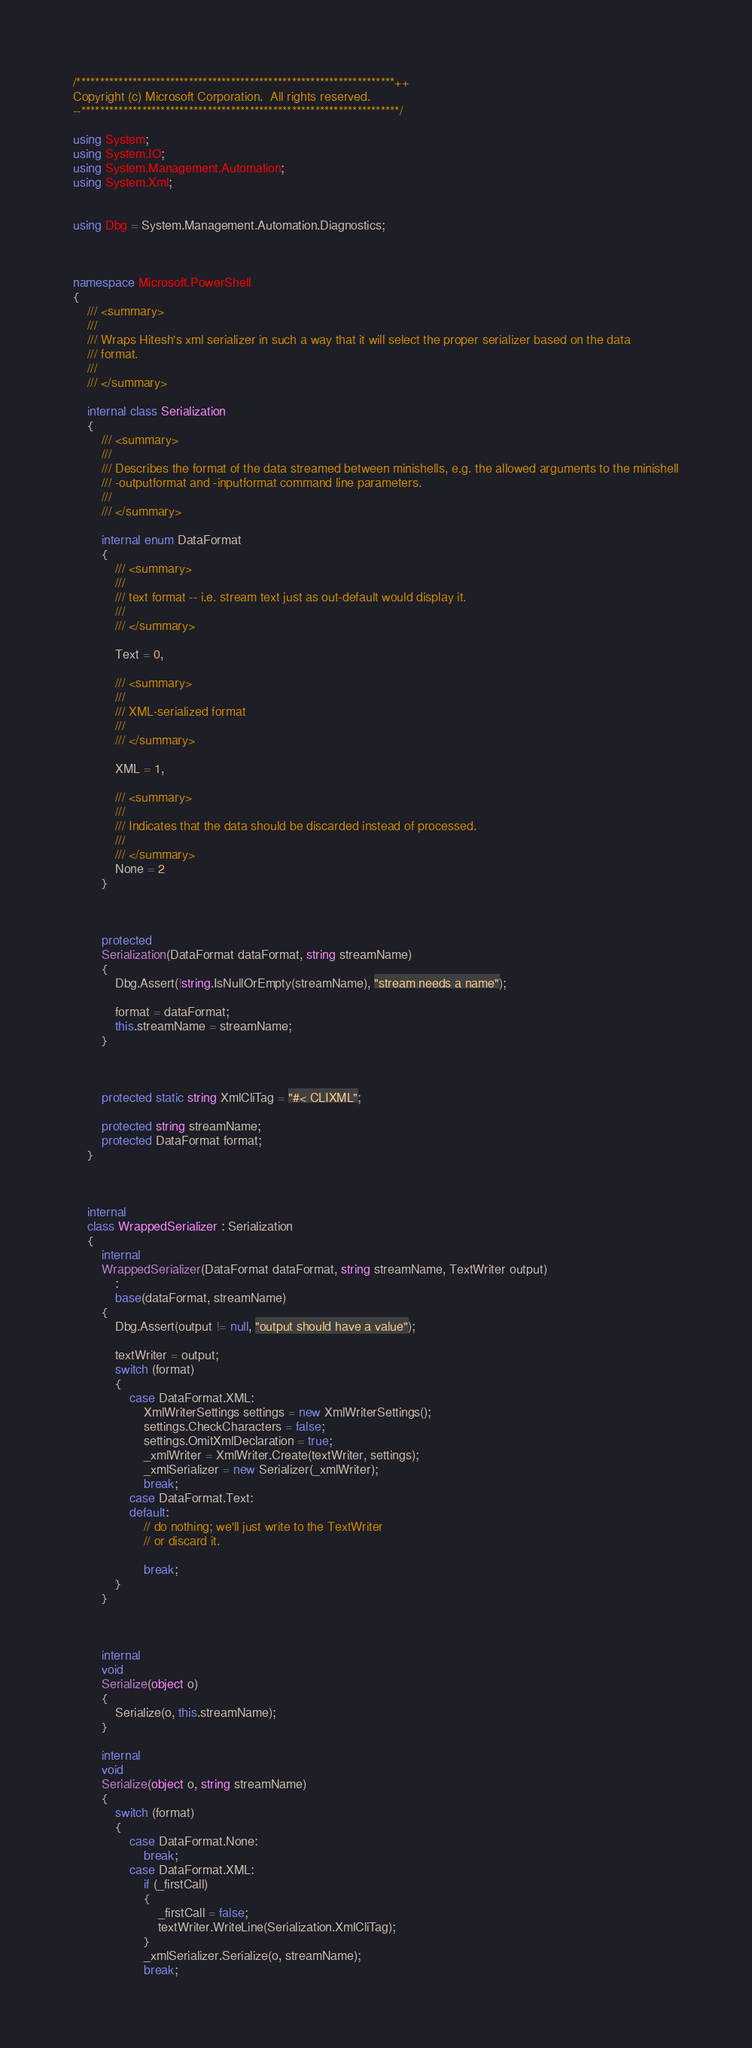<code> <loc_0><loc_0><loc_500><loc_500><_C#_>/********************************************************************++
Copyright (c) Microsoft Corporation.  All rights reserved.
--********************************************************************/

using System;
using System.IO;
using System.Management.Automation;
using System.Xml;


using Dbg = System.Management.Automation.Diagnostics;



namespace Microsoft.PowerShell
{
    /// <summary>
    ///
    /// Wraps Hitesh's xml serializer in such a way that it will select the proper serializer based on the data
    /// format.
    ///
    /// </summary>

    internal class Serialization
    {
        /// <summary>
        ///
        /// Describes the format of the data streamed between minishells, e.g. the allowed arguments to the minishell
        /// -outputformat and -inputformat command line parameters.
        ///
        /// </summary>

        internal enum DataFormat
        {
            /// <summary>
            ///
            /// text format -- i.e. stream text just as out-default would display it.
            ///
            /// </summary>

            Text = 0,

            /// <summary>
            ///
            /// XML-serialized format
            ///
            /// </summary>

            XML = 1,

            /// <summary>
            ///
            /// Indicates that the data should be discarded instead of processed.
            ///
            /// </summary>
            None = 2
        }



        protected
        Serialization(DataFormat dataFormat, string streamName)
        {
            Dbg.Assert(!string.IsNullOrEmpty(streamName), "stream needs a name");

            format = dataFormat;
            this.streamName = streamName;
        }



        protected static string XmlCliTag = "#< CLIXML";

        protected string streamName;
        protected DataFormat format;
    }



    internal
    class WrappedSerializer : Serialization
    {
        internal
        WrappedSerializer(DataFormat dataFormat, string streamName, TextWriter output)
            :
            base(dataFormat, streamName)
        {
            Dbg.Assert(output != null, "output should have a value");

            textWriter = output;
            switch (format)
            {
                case DataFormat.XML:
                    XmlWriterSettings settings = new XmlWriterSettings();
                    settings.CheckCharacters = false;
                    settings.OmitXmlDeclaration = true;
                    _xmlWriter = XmlWriter.Create(textWriter, settings);
                    _xmlSerializer = new Serializer(_xmlWriter);
                    break;
                case DataFormat.Text:
                default:
                    // do nothing; we'll just write to the TextWriter
                    // or discard it.

                    break;
            }
        }



        internal
        void
        Serialize(object o)
        {
            Serialize(o, this.streamName);
        }

        internal
        void
        Serialize(object o, string streamName)
        {
            switch (format)
            {
                case DataFormat.None:
                    break;
                case DataFormat.XML:
                    if (_firstCall)
                    {
                        _firstCall = false;
                        textWriter.WriteLine(Serialization.XmlCliTag);
                    }
                    _xmlSerializer.Serialize(o, streamName);
                    break;</code> 